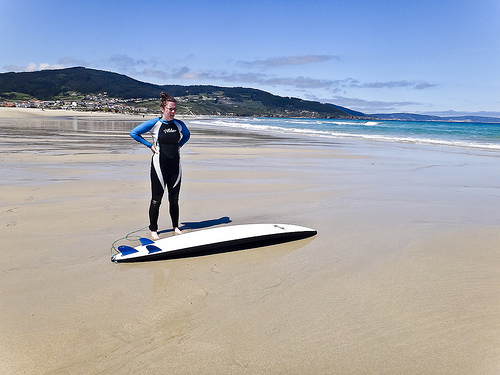Please provide a short description for this region: [0.02, 0.29, 0.29, 0.36]. This region captures a picturesque coastal area featuring a charming small beach town, where quaint houses and local establishments can be observed bustling with activity. 